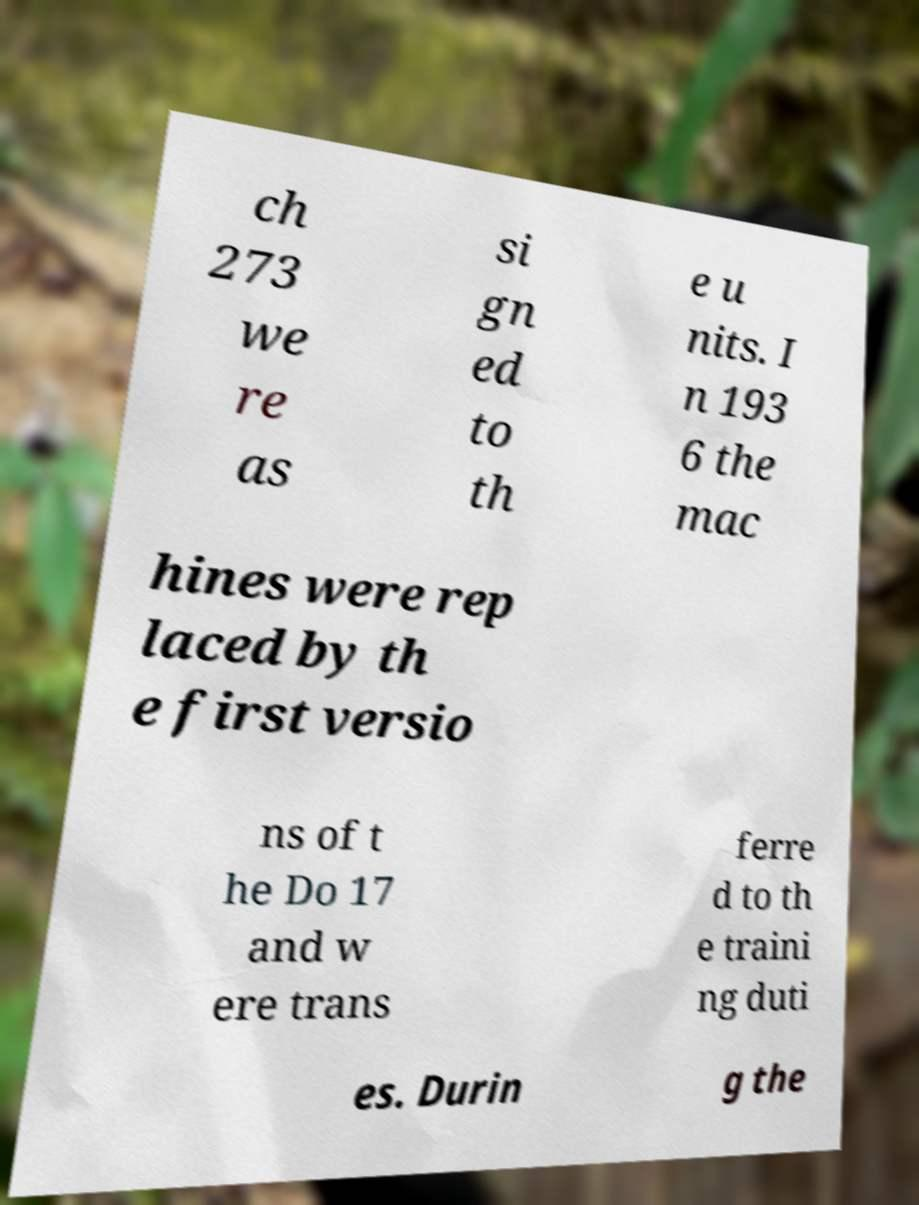I need the written content from this picture converted into text. Can you do that? ch 273 we re as si gn ed to th e u nits. I n 193 6 the mac hines were rep laced by th e first versio ns of t he Do 17 and w ere trans ferre d to th e traini ng duti es. Durin g the 